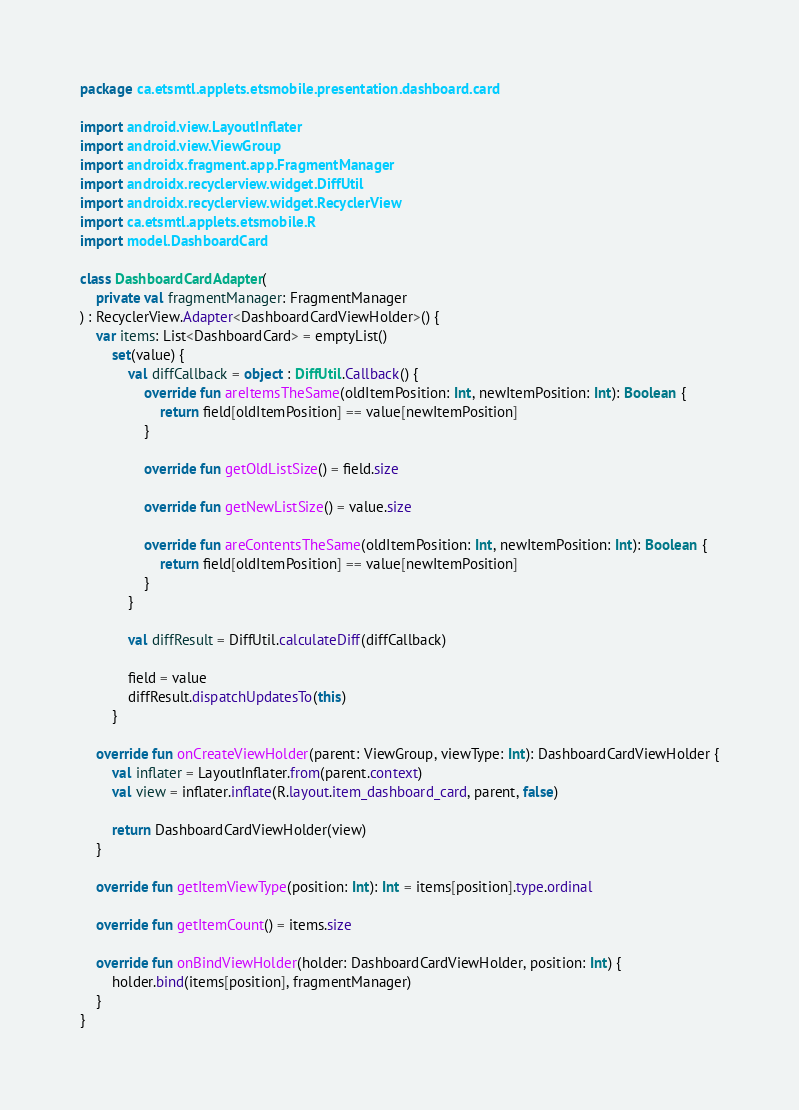Convert code to text. <code><loc_0><loc_0><loc_500><loc_500><_Kotlin_>package ca.etsmtl.applets.etsmobile.presentation.dashboard.card

import android.view.LayoutInflater
import android.view.ViewGroup
import androidx.fragment.app.FragmentManager
import androidx.recyclerview.widget.DiffUtil
import androidx.recyclerview.widget.RecyclerView
import ca.etsmtl.applets.etsmobile.R
import model.DashboardCard

class DashboardCardAdapter(
    private val fragmentManager: FragmentManager
) : RecyclerView.Adapter<DashboardCardViewHolder>() {
    var items: List<DashboardCard> = emptyList()
        set(value) {
            val diffCallback = object : DiffUtil.Callback() {
                override fun areItemsTheSame(oldItemPosition: Int, newItemPosition: Int): Boolean {
                    return field[oldItemPosition] == value[newItemPosition]
                }

                override fun getOldListSize() = field.size

                override fun getNewListSize() = value.size

                override fun areContentsTheSame(oldItemPosition: Int, newItemPosition: Int): Boolean {
                    return field[oldItemPosition] == value[newItemPosition]
                }
            }

            val diffResult = DiffUtil.calculateDiff(diffCallback)

            field = value
            diffResult.dispatchUpdatesTo(this)
        }

    override fun onCreateViewHolder(parent: ViewGroup, viewType: Int): DashboardCardViewHolder {
        val inflater = LayoutInflater.from(parent.context)
        val view = inflater.inflate(R.layout.item_dashboard_card, parent, false)

        return DashboardCardViewHolder(view)
    }

    override fun getItemViewType(position: Int): Int = items[position].type.ordinal

    override fun getItemCount() = items.size

    override fun onBindViewHolder(holder: DashboardCardViewHolder, position: Int) {
        holder.bind(items[position], fragmentManager)
    }
}</code> 